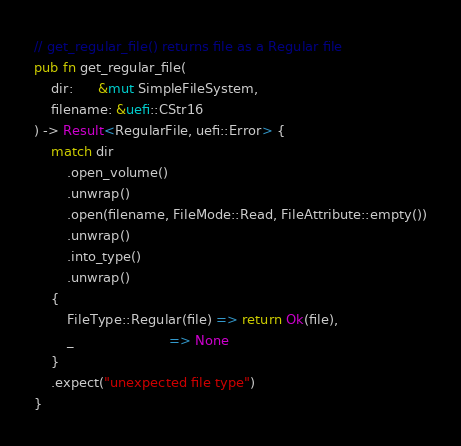<code> <loc_0><loc_0><loc_500><loc_500><_Rust_>// get_regular_file() returns file as a Regular file
pub fn get_regular_file(
    dir:      &mut SimpleFileSystem,
    filename: &uefi::CStr16
) -> Result<RegularFile, uefi::Error> {
    match dir 
        .open_volume()
        .unwrap()
        .open(filename, FileMode::Read, FileAttribute::empty())
        .unwrap()
        .into_type()
        .unwrap()
    {
        FileType::Regular(file) => return Ok(file),
        _                       => None
    }
    .expect("unexpected file type")
}
</code> 